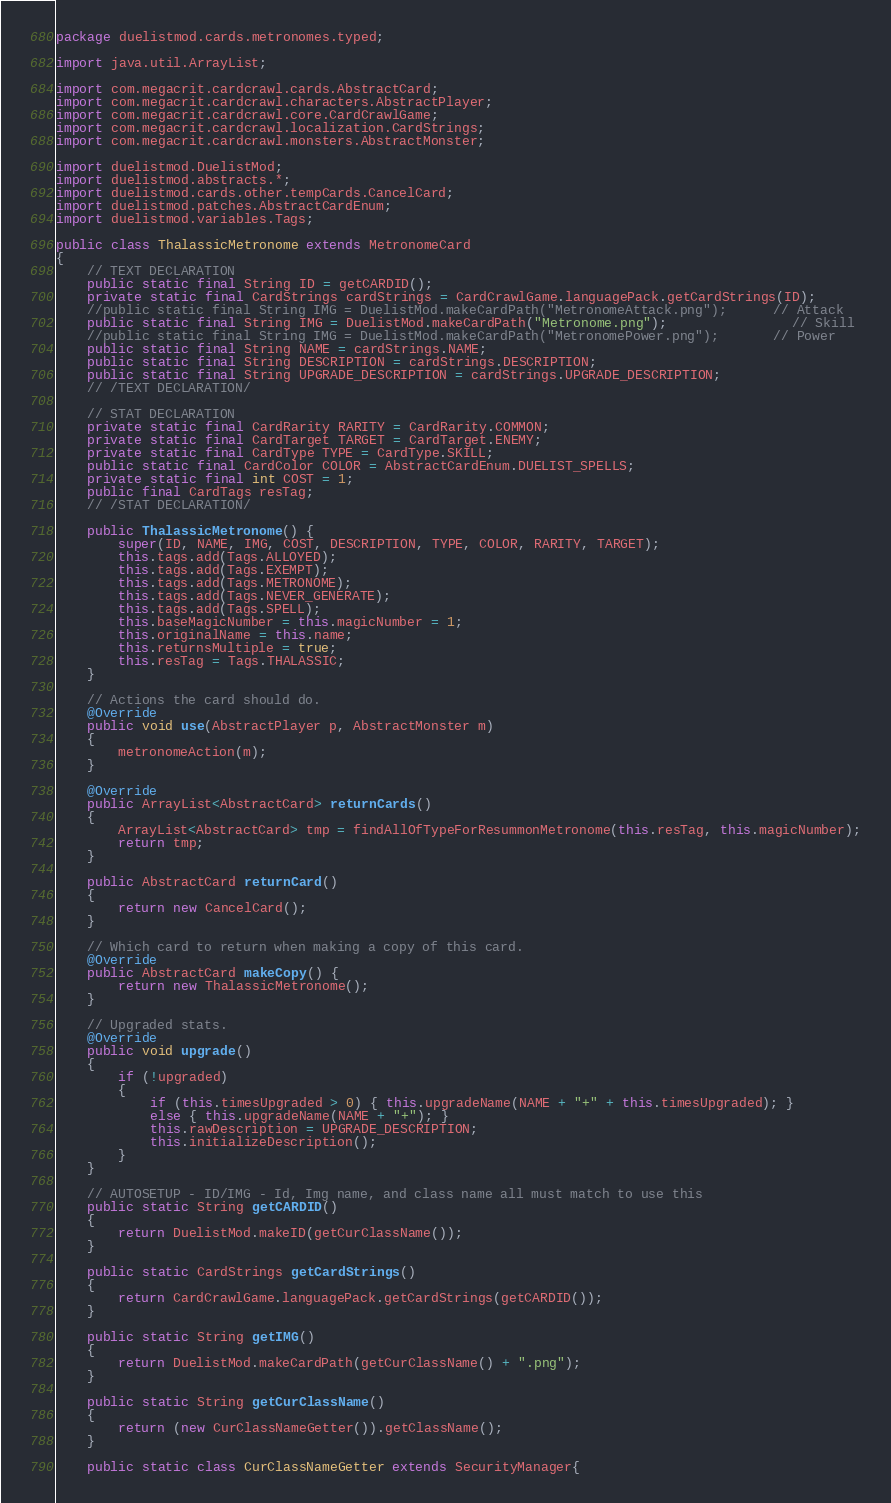Convert code to text. <code><loc_0><loc_0><loc_500><loc_500><_Java_>package duelistmod.cards.metronomes.typed;

import java.util.ArrayList;

import com.megacrit.cardcrawl.cards.AbstractCard;
import com.megacrit.cardcrawl.characters.AbstractPlayer;
import com.megacrit.cardcrawl.core.CardCrawlGame;
import com.megacrit.cardcrawl.localization.CardStrings;
import com.megacrit.cardcrawl.monsters.AbstractMonster;

import duelistmod.DuelistMod;
import duelistmod.abstracts.*;
import duelistmod.cards.other.tempCards.CancelCard;
import duelistmod.patches.AbstractCardEnum;
import duelistmod.variables.Tags;

public class ThalassicMetronome extends MetronomeCard 
{
    // TEXT DECLARATION
    public static final String ID = getCARDID();
    private static final CardStrings cardStrings = CardCrawlGame.languagePack.getCardStrings(ID);
    //public static final String IMG = DuelistMod.makeCardPath("MetronomeAttack.png");		// Attack
    public static final String IMG = DuelistMod.makeCardPath("Metronome.png");				// Skill
    //public static final String IMG = DuelistMod.makeCardPath("MetronomePower.png");		// Power
    public static final String NAME = cardStrings.NAME;
    public static final String DESCRIPTION = cardStrings.DESCRIPTION;
    public static final String UPGRADE_DESCRIPTION = cardStrings.UPGRADE_DESCRIPTION;
    // /TEXT DECLARATION/

    // STAT DECLARATION
    private static final CardRarity RARITY = CardRarity.COMMON;
    private static final CardTarget TARGET = CardTarget.ENEMY;
    private static final CardType TYPE = CardType.SKILL;
    public static final CardColor COLOR = AbstractCardEnum.DUELIST_SPELLS;
    private static final int COST = 1;
    public final CardTags resTag;
    // /STAT DECLARATION/

    public ThalassicMetronome() {
        super(ID, NAME, IMG, COST, DESCRIPTION, TYPE, COLOR, RARITY, TARGET);
        this.tags.add(Tags.ALLOYED);
        this.tags.add(Tags.EXEMPT);
        this.tags.add(Tags.METRONOME);
        this.tags.add(Tags.NEVER_GENERATE);
        this.tags.add(Tags.SPELL);
        this.baseMagicNumber = this.magicNumber = 1;
        this.originalName = this.name;       
        this.returnsMultiple = true;
        this.resTag = Tags.THALASSIC;
    }

    // Actions the card should do.
    @Override
    public void use(AbstractPlayer p, AbstractMonster m) 
    {
    	metronomeAction(m);
    }
    
    @Override
	public ArrayList<AbstractCard> returnCards()
	{
		ArrayList<AbstractCard> tmp = findAllOfTypeForResummonMetronome(this.resTag, this.magicNumber);
		return tmp;
	}
    
    public AbstractCard returnCard()
    {
		return new CancelCard();				
    }

    // Which card to return when making a copy of this card.
    @Override
    public AbstractCard makeCopy() {
        return new ThalassicMetronome();
    }

    // Upgraded stats.
    @Override
    public void upgrade() 
    {
        if (!upgraded)
        {
        	if (this.timesUpgraded > 0) { this.upgradeName(NAME + "+" + this.timesUpgraded); }
	    	else { this.upgradeName(NAME + "+"); }
            this.rawDescription = UPGRADE_DESCRIPTION;
            this.initializeDescription();
        }
    }
    
    // AUTOSETUP - ID/IMG - Id, Img name, and class name all must match to use this
    public static String getCARDID()
    {
    	return DuelistMod.makeID(getCurClassName());
    }
    
	public static CardStrings getCardStrings()
    {
    	return CardCrawlGame.languagePack.getCardStrings(getCARDID());
    }
    
    public static String getIMG()
    {
    	return DuelistMod.makeCardPath(getCurClassName() + ".png");
    }
    
    public static String getCurClassName()
    {
    	return (new CurClassNameGetter()).getClassName();
    }

    public static class CurClassNameGetter extends SecurityManager{</code> 